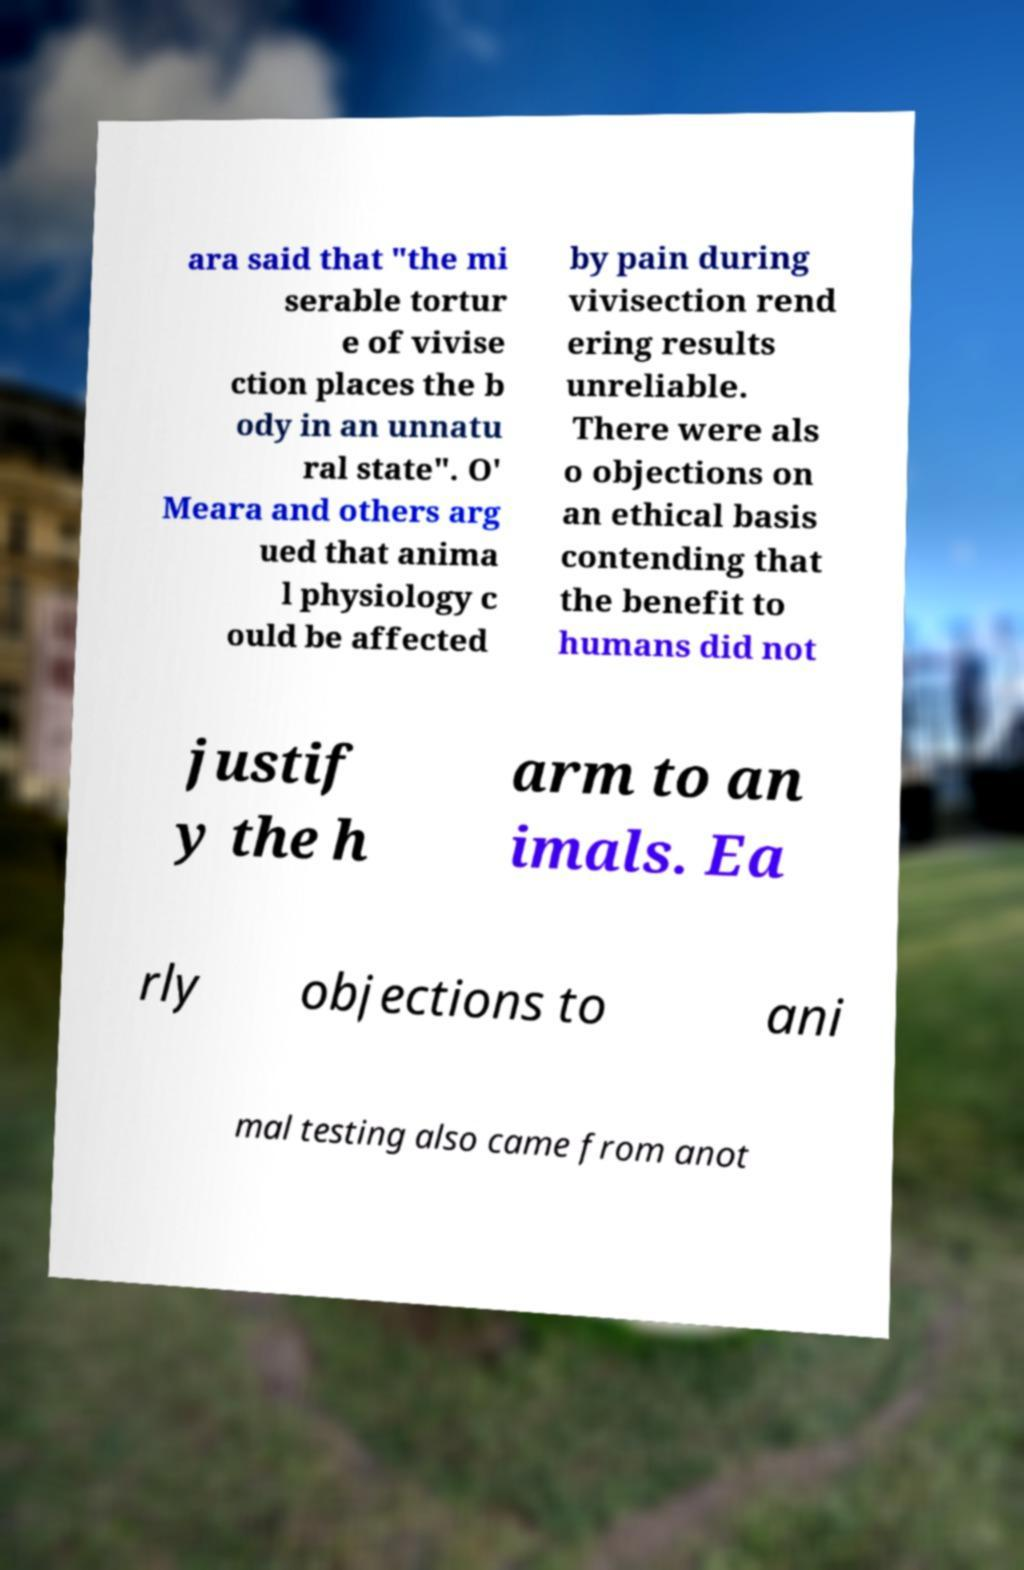Can you read and provide the text displayed in the image?This photo seems to have some interesting text. Can you extract and type it out for me? ara said that "the mi serable tortur e of vivise ction places the b ody in an unnatu ral state". O' Meara and others arg ued that anima l physiology c ould be affected by pain during vivisection rend ering results unreliable. There were als o objections on an ethical basis contending that the benefit to humans did not justif y the h arm to an imals. Ea rly objections to ani mal testing also came from anot 